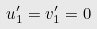<formula> <loc_0><loc_0><loc_500><loc_500>u ^ { \prime } _ { 1 } = v ^ { \prime } _ { 1 } = 0</formula> 